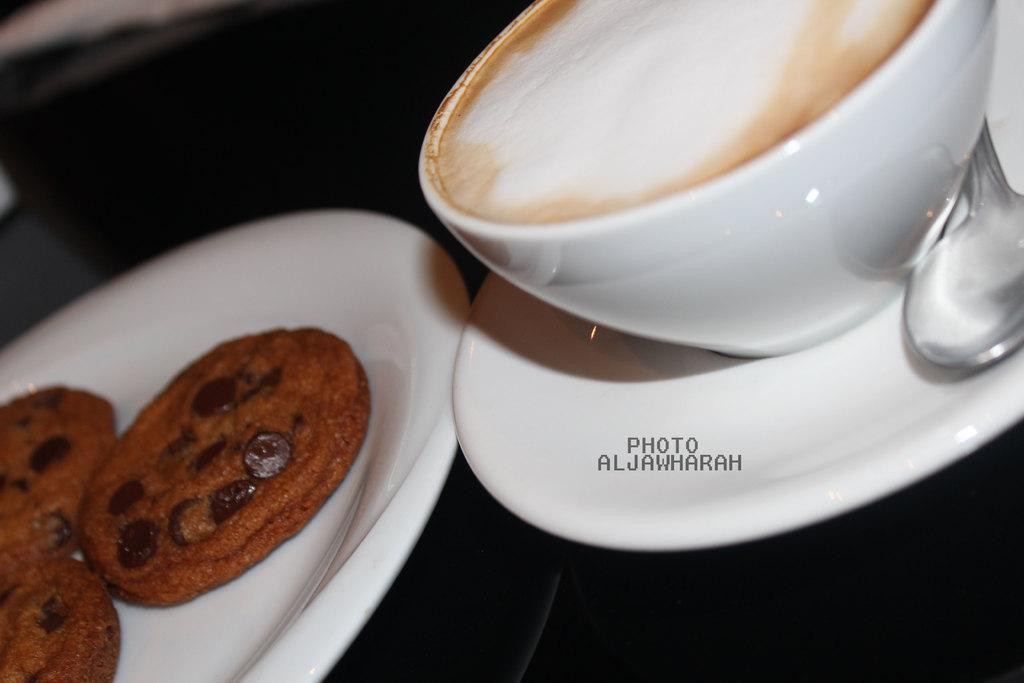How would you summarize this image in a sentence or two? In this image there are cookies on the plate. And there is a cup and saucer and a spoon. 